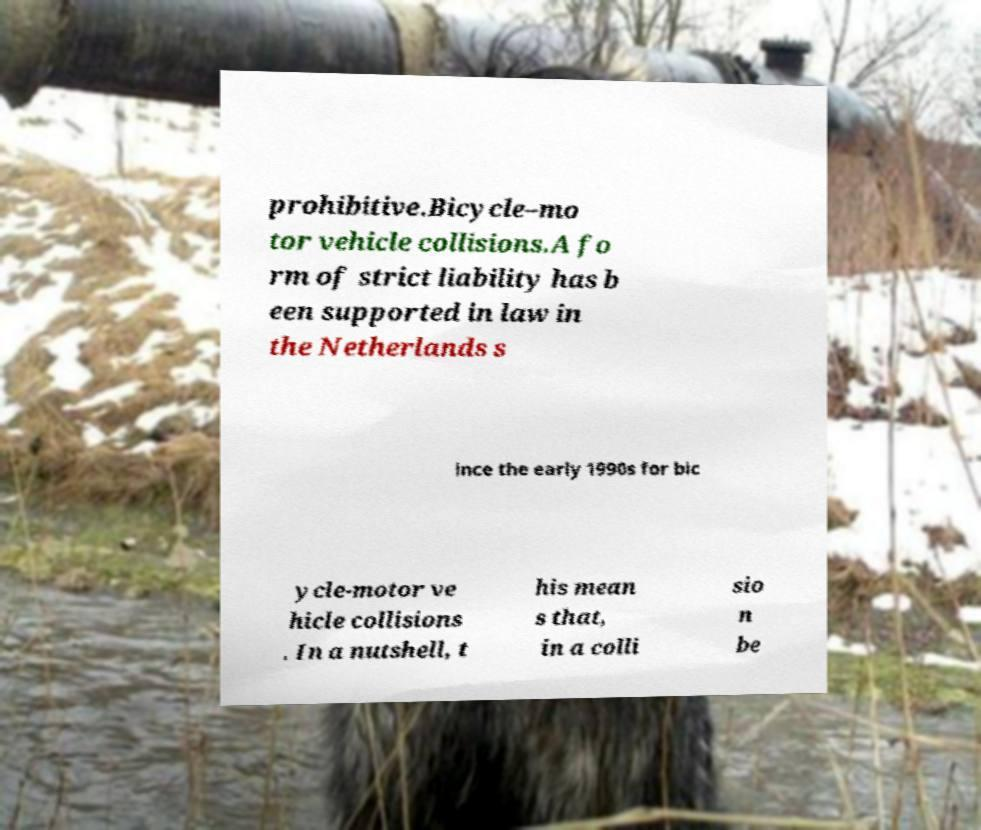What messages or text are displayed in this image? I need them in a readable, typed format. prohibitive.Bicycle–mo tor vehicle collisions.A fo rm of strict liability has b een supported in law in the Netherlands s ince the early 1990s for bic ycle-motor ve hicle collisions . In a nutshell, t his mean s that, in a colli sio n be 